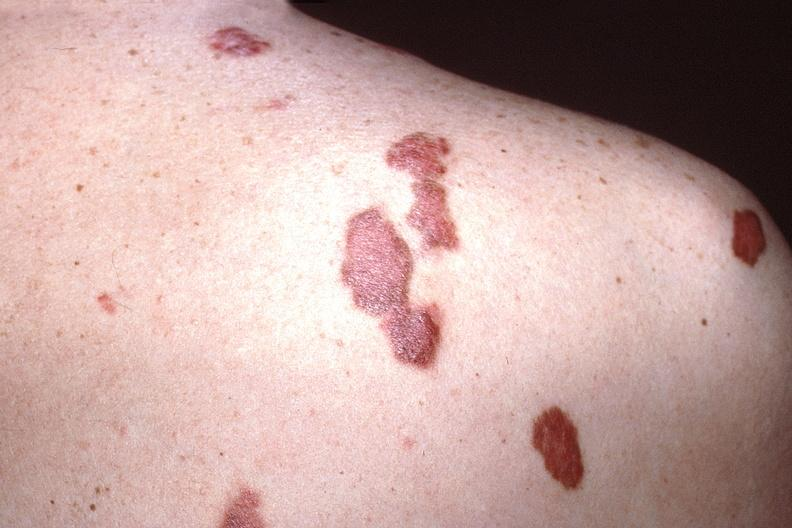what does this image show?
Answer the question using a single word or phrase. Skin 